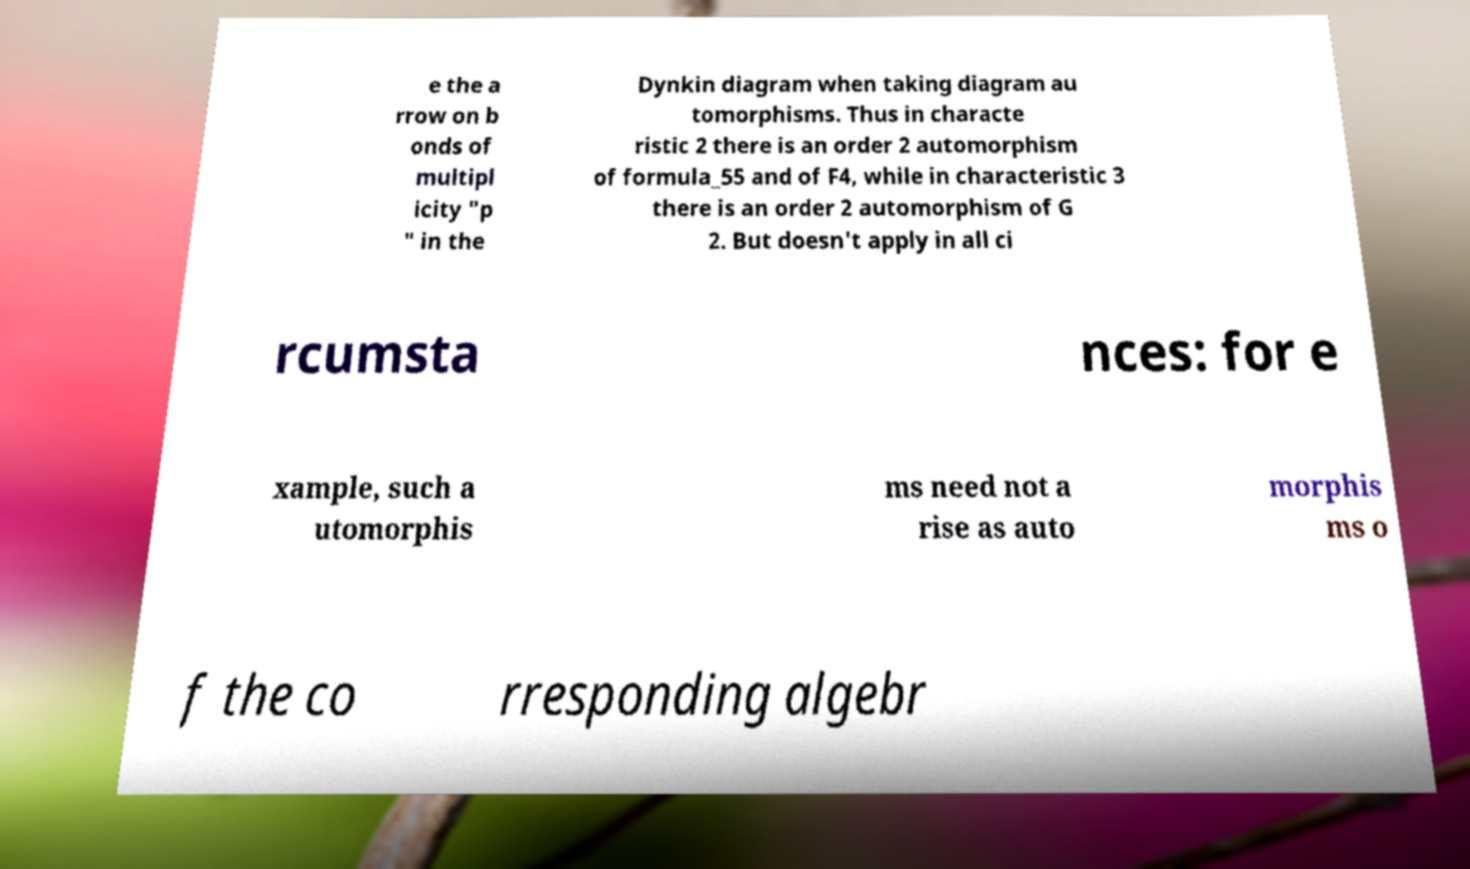What messages or text are displayed in this image? I need them in a readable, typed format. e the a rrow on b onds of multipl icity "p " in the Dynkin diagram when taking diagram au tomorphisms. Thus in characte ristic 2 there is an order 2 automorphism of formula_55 and of F4, while in characteristic 3 there is an order 2 automorphism of G 2. But doesn't apply in all ci rcumsta nces: for e xample, such a utomorphis ms need not a rise as auto morphis ms o f the co rresponding algebr 